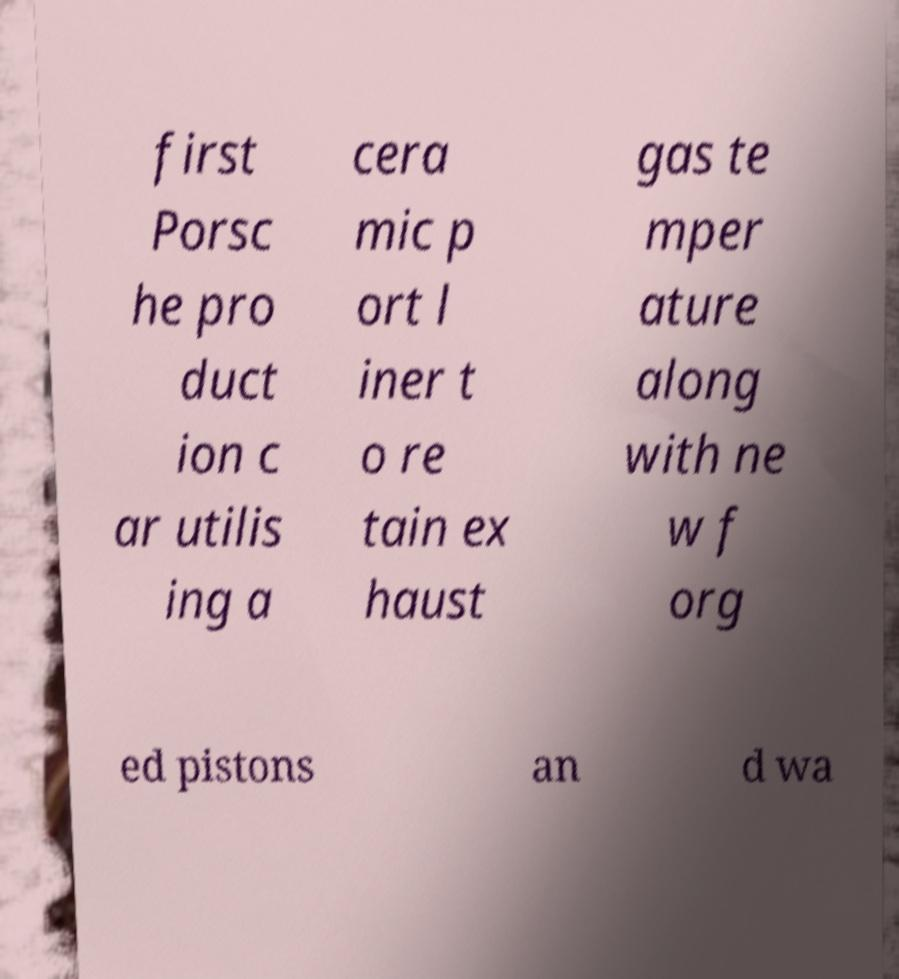Can you read and provide the text displayed in the image?This photo seems to have some interesting text. Can you extract and type it out for me? first Porsc he pro duct ion c ar utilis ing a cera mic p ort l iner t o re tain ex haust gas te mper ature along with ne w f org ed pistons an d wa 